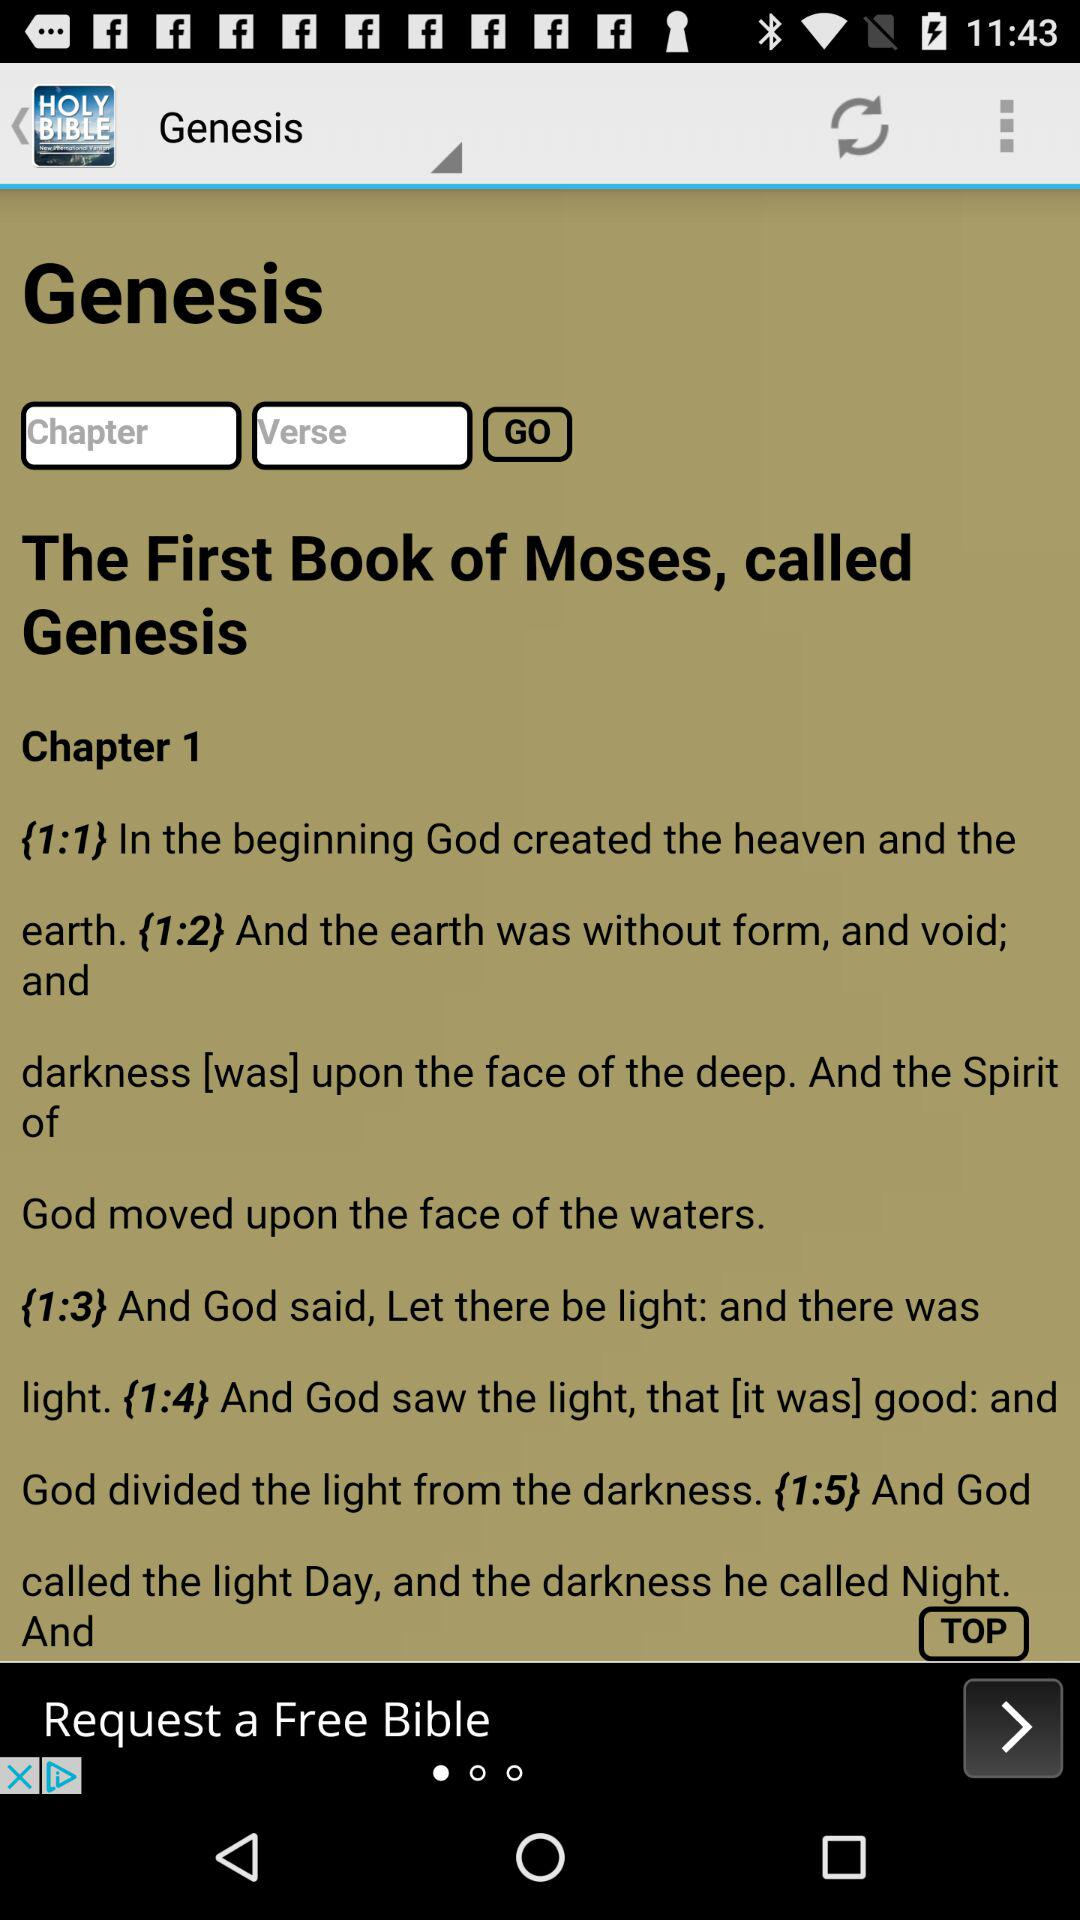What is the application name? The application name is "HOLY BIBLE". 